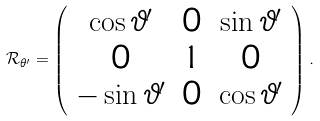<formula> <loc_0><loc_0><loc_500><loc_500>\mathcal { R } _ { \theta ^ { \prime } } = \left ( \begin{array} { c c c } \cos \vartheta ^ { \prime } & 0 & \sin \vartheta ^ { \prime } \\ 0 & 1 & 0 \\ - \sin \vartheta ^ { \prime } & 0 & \cos \vartheta ^ { \prime } \end{array} \right ) .</formula> 